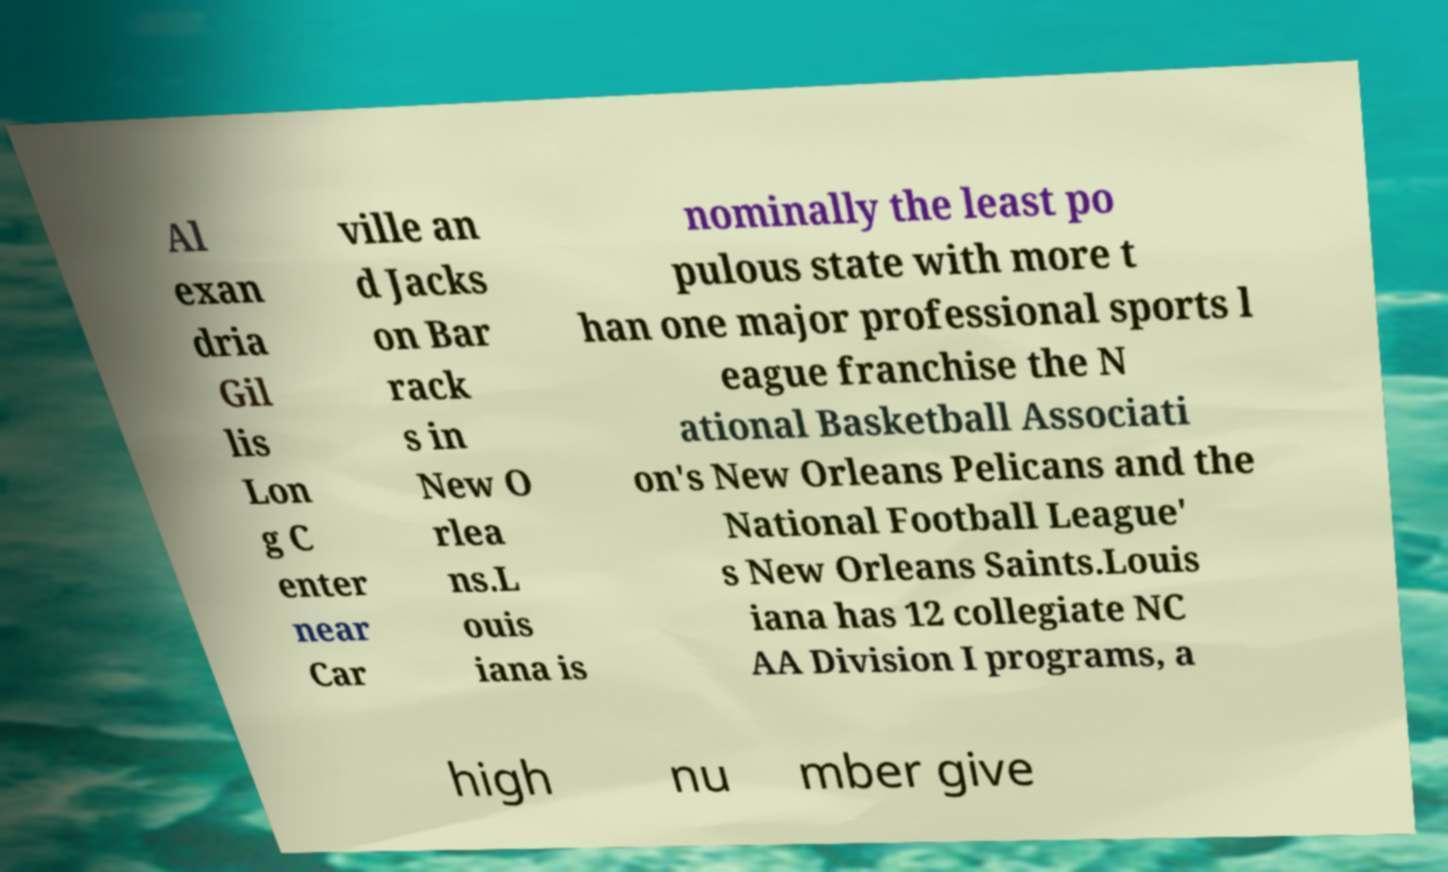I need the written content from this picture converted into text. Can you do that? Al exan dria Gil lis Lon g C enter near Car ville an d Jacks on Bar rack s in New O rlea ns.L ouis iana is nominally the least po pulous state with more t han one major professional sports l eague franchise the N ational Basketball Associati on's New Orleans Pelicans and the National Football League' s New Orleans Saints.Louis iana has 12 collegiate NC AA Division I programs, a high nu mber give 